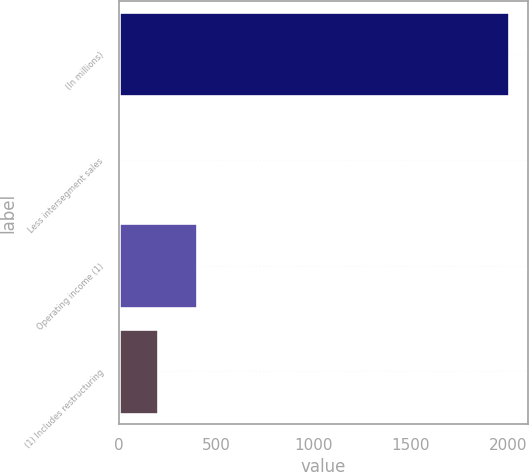<chart> <loc_0><loc_0><loc_500><loc_500><bar_chart><fcel>(In millions)<fcel>Less intersegment sales<fcel>Operating income (1)<fcel>(1) Includes restructuring<nl><fcel>2006<fcel>1.8<fcel>402.64<fcel>202.22<nl></chart> 